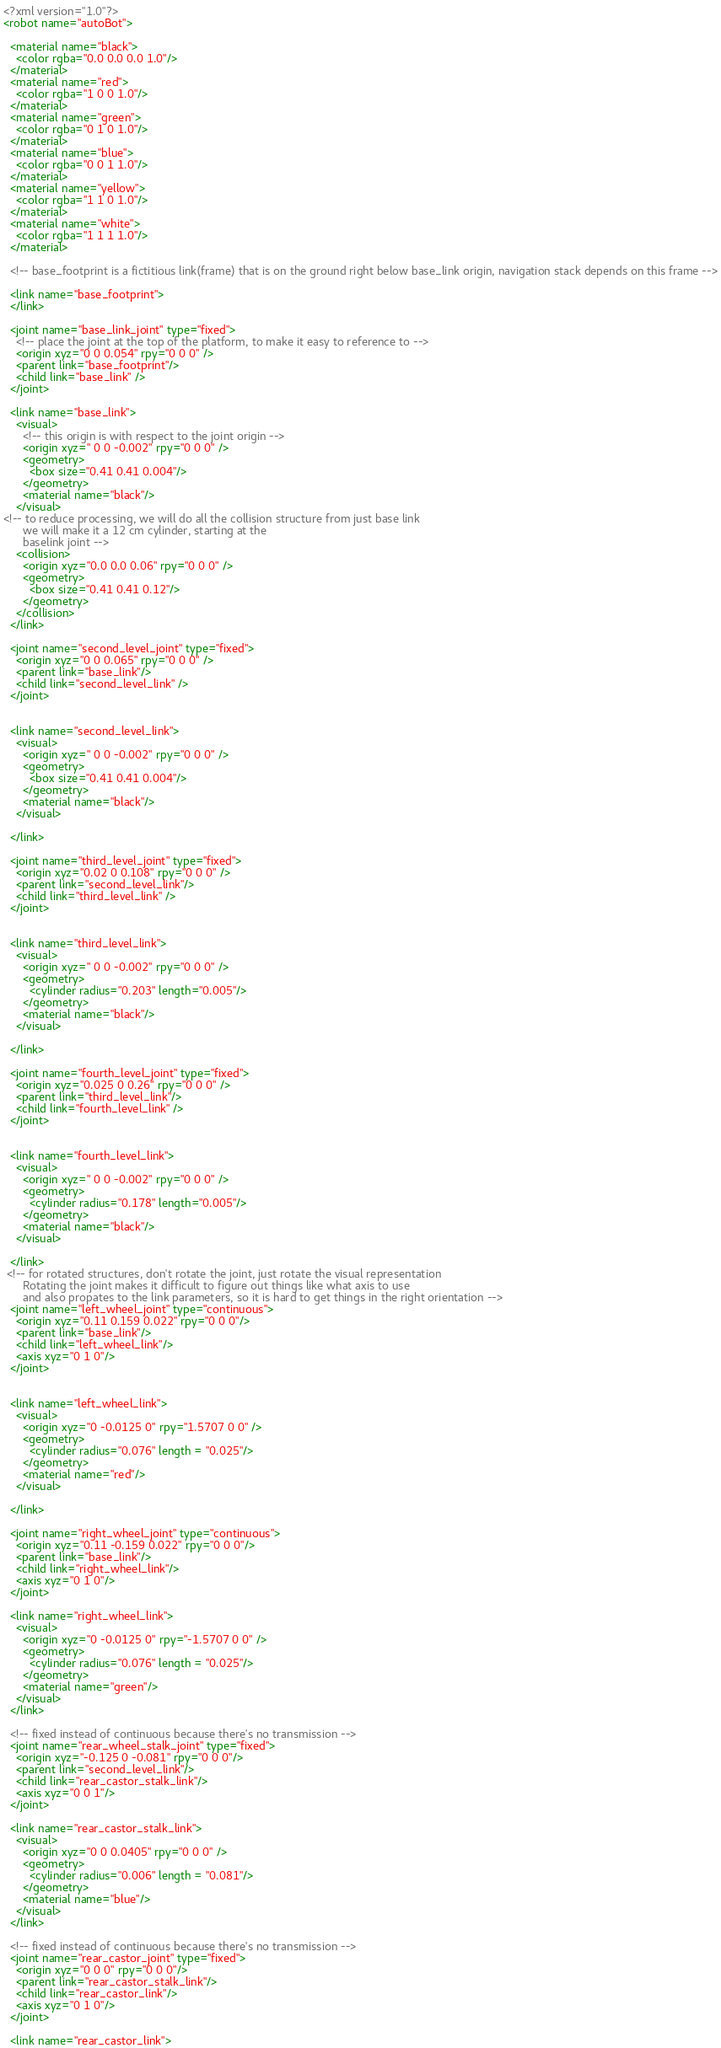<code> <loc_0><loc_0><loc_500><loc_500><_XML_><?xml version="1.0"?>
<robot name="autoBot">

  <material name="black">
    <color rgba="0.0 0.0 0.0 1.0"/>
  </material>
  <material name="red">
    <color rgba="1 0 0 1.0"/>
  </material>
  <material name="green">
    <color rgba="0 1 0 1.0"/>
  </material>
  <material name="blue">
    <color rgba="0 0 1 1.0"/>
  </material>
  <material name="yellow">
    <color rgba="1 1 0 1.0"/>
  </material>
  <material name="white">
    <color rgba="1 1 1 1.0"/>
  </material>

  <!-- base_footprint is a fictitious link(frame) that is on the ground right below base_link origin, navigation stack depends on this frame -->

  <link name="base_footprint">
  </link>

  <joint name="base_link_joint" type="fixed">
    <!-- place the joint at the top of the platform, to make it easy to reference to -->
    <origin xyz="0 0 0.054" rpy="0 0 0" />        
    <parent link="base_footprint"/>
    <child link="base_link" />
  </joint>

  <link name="base_link">
    <visual>
      <!-- this origin is with respect to the joint origin -->
      <origin xyz=" 0 0 -0.002" rpy="0 0 0" />
      <geometry>
        <box size="0.41 0.41 0.004"/>
      </geometry>
      <material name="black"/>
    </visual>
<!-- to reduce processing, we will do all the collision structure from just base link
      we will make it a 12 cm cylinder, starting at the
      baselink joint -->
    <collision>
      <origin xyz="0.0 0.0 0.06" rpy="0 0 0" />
      <geometry>
        <box size="0.41 0.41 0.12"/>
      </geometry>
    </collision>
  </link>

  <joint name="second_level_joint" type="fixed">
    <origin xyz="0 0 0.065" rpy="0 0 0" />        
    <parent link="base_link"/>
    <child link="second_level_link" />
  </joint>


  <link name="second_level_link">
    <visual>
      <origin xyz=" 0 0 -0.002" rpy="0 0 0" />
      <geometry>
        <box size="0.41 0.41 0.004"/>
      </geometry>
      <material name="black"/>
    </visual>

  </link>

  <joint name="third_level_joint" type="fixed">
    <origin xyz="0.02 0 0.108" rpy="0 0 0" />        
    <parent link="second_level_link"/>
    <child link="third_level_link" />
  </joint>


  <link name="third_level_link">
    <visual>
      <origin xyz=" 0 0 -0.002" rpy="0 0 0" />
      <geometry>
        <cylinder radius="0.203" length="0.005"/>
      </geometry>
      <material name="black"/>
    </visual>

  </link>

  <joint name="fourth_level_joint" type="fixed">
    <origin xyz="0.025 0 0.26" rpy="0 0 0" />        
    <parent link="third_level_link"/>
    <child link="fourth_level_link" />
  </joint>


  <link name="fourth_level_link">
    <visual>
      <origin xyz=" 0 0 -0.002" rpy="0 0 0" />
      <geometry>
        <cylinder radius="0.178" length="0.005"/>
      </geometry>
      <material name="black"/>
    </visual>

  </link>
 <!-- for rotated structures, don't rotate the joint, just rotate the visual representation
      Rotating the joint makes it difficult to figure out things like what axis to use
      and also propates to the link parameters, so it is hard to get things in the right orientation -->
  <joint name="left_wheel_joint" type="continuous">
    <origin xyz="0.11 0.159 0.022" rpy="0 0 0"/>
    <parent link="base_link"/>
    <child link="left_wheel_link"/>
    <axis xyz="0 1 0"/>
  </joint>


  <link name="left_wheel_link">
    <visual>
      <origin xyz="0 -0.0125 0" rpy="1.5707 0 0" />
      <geometry>
        <cylinder radius="0.076" length = "0.025"/>
      </geometry>
      <material name="red"/>
    </visual>

  </link>

  <joint name="right_wheel_joint" type="continuous">
    <origin xyz="0.11 -0.159 0.022" rpy="0 0 0"/>
    <parent link="base_link"/>
    <child link="right_wheel_link"/>
    <axis xyz="0 1 0"/>
  </joint>

  <link name="right_wheel_link">
    <visual>
      <origin xyz="0 -0.0125 0" rpy="-1.5707 0 0" />
      <geometry>
        <cylinder radius="0.076" length = "0.025"/>
      </geometry>
      <material name="green"/>
    </visual>
  </link>

  <!-- fixed instead of continuous because there's no transmission -->
  <joint name="rear_wheel_stalk_joint" type="fixed">
    <origin xyz="-0.125 0 -0.081" rpy="0 0 0"/>
    <parent link="second_level_link"/>
    <child link="rear_castor_stalk_link"/>
    <axis xyz="0 0 1"/>
  </joint>

  <link name="rear_castor_stalk_link">
    <visual>
      <origin xyz="0 0 0.0405" rpy="0 0 0" />
      <geometry>
        <cylinder radius="0.006" length = "0.081"/>
      </geometry>
      <material name="blue"/>
    </visual>
  </link>

  <!-- fixed instead of continuous because there's no transmission -->
  <joint name="rear_castor_joint" type="fixed">
    <origin xyz="0 0 0" rpy="0 0 0"/>
    <parent link="rear_castor_stalk_link"/>
    <child link="rear_castor_link"/>
    <axis xyz="0 1 0"/>
  </joint>

  <link name="rear_castor_link"></code> 